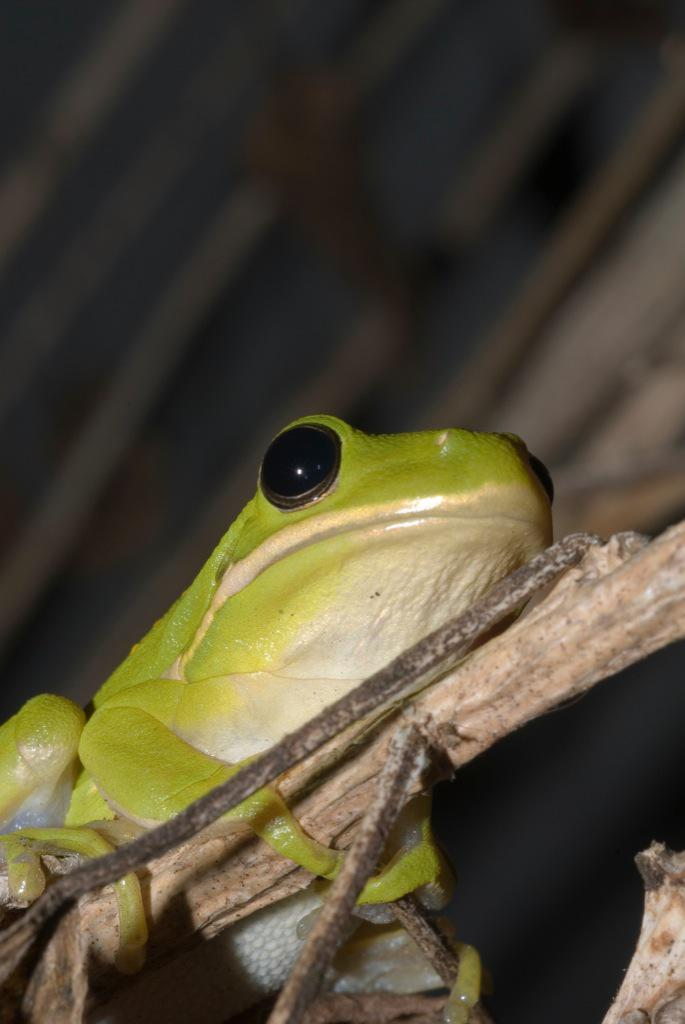What type of animal is in the image? There is a frog in the image. What is the frog sitting on? The frog is on a wooden stick. Are there any other wooden sticks visible in the image? Yes, there are wooden sticks visible in the background of the image. What type of yard is visible in the image? There is no yard visible in the image; it features a frog on a wooden stick and other wooden sticks in the background. What type of animal is being traded in the image? There is no animal being traded in the image; it features a frog on a wooden stick and other wooden sticks in the background. 